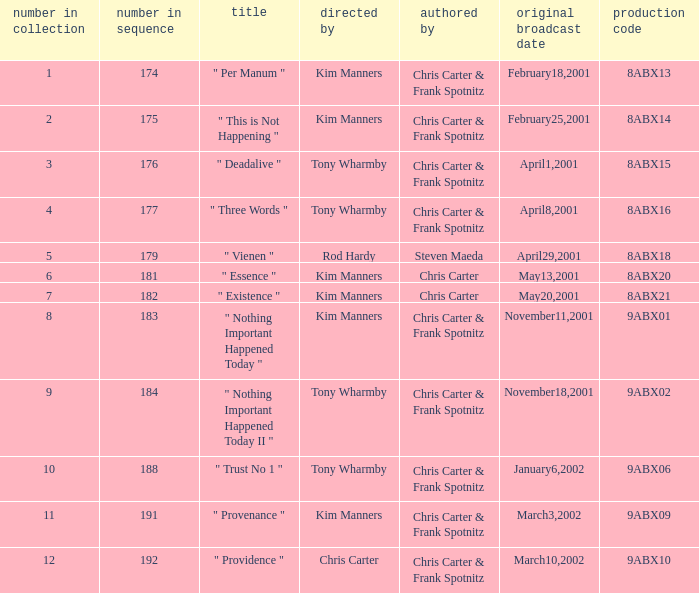The episode with production code 9abx02 was originally aired on what date? November18,2001. 